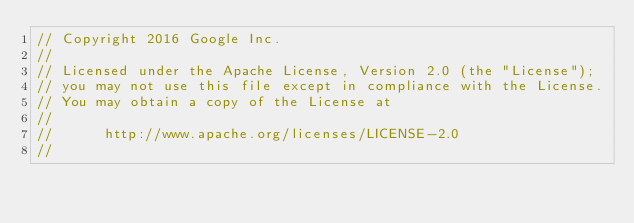<code> <loc_0><loc_0><loc_500><loc_500><_Go_>// Copyright 2016 Google Inc.
//
// Licensed under the Apache License, Version 2.0 (the "License");
// you may not use this file except in compliance with the License.
// You may obtain a copy of the License at
//
//      http://www.apache.org/licenses/LICENSE-2.0
//</code> 